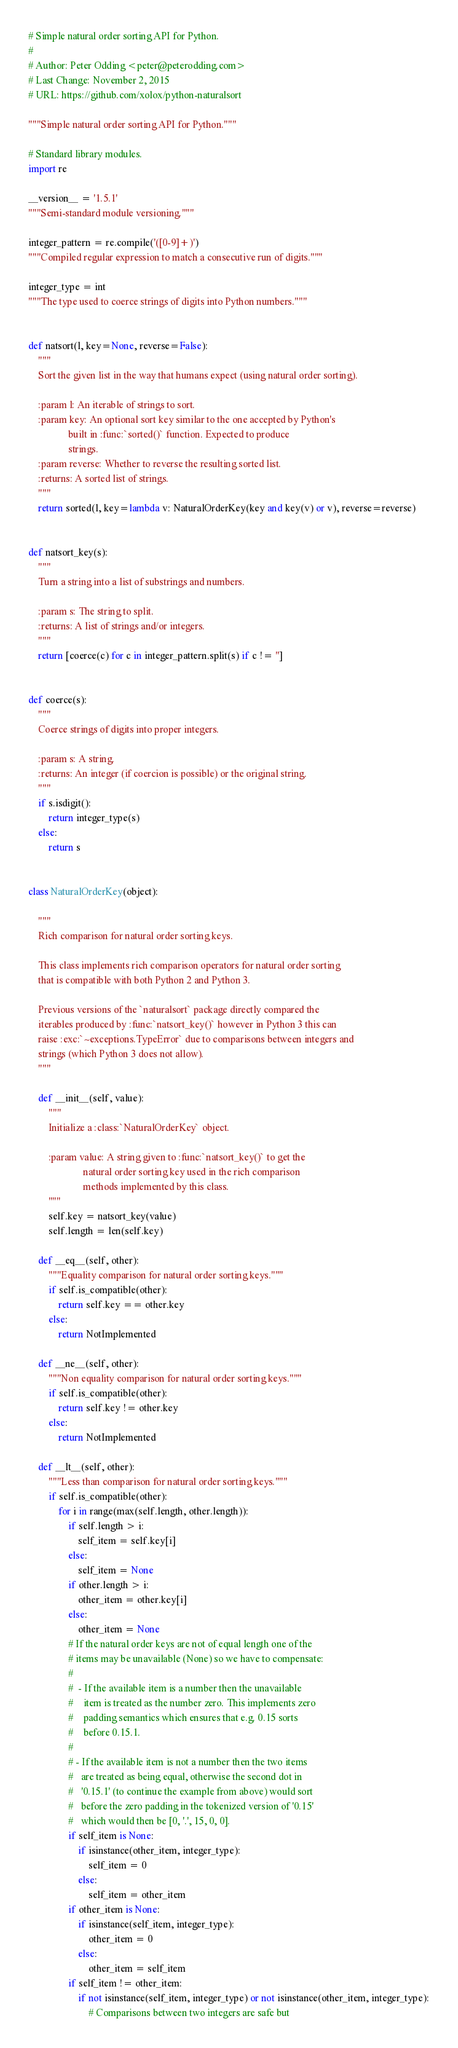<code> <loc_0><loc_0><loc_500><loc_500><_Python_># Simple natural order sorting API for Python.
#
# Author: Peter Odding <peter@peterodding.com>
# Last Change: November 2, 2015
# URL: https://github.com/xolox/python-naturalsort

"""Simple natural order sorting API for Python."""

# Standard library modules.
import re

__version__ = '1.5.1'
"""Semi-standard module versioning."""

integer_pattern = re.compile('([0-9]+)')
"""Compiled regular expression to match a consecutive run of digits."""

integer_type = int
"""The type used to coerce strings of digits into Python numbers."""


def natsort(l, key=None, reverse=False):
    """
    Sort the given list in the way that humans expect (using natural order sorting).

    :param l: An iterable of strings to sort.
    :param key: An optional sort key similar to the one accepted by Python's
                built in :func:`sorted()` function. Expected to produce
                strings.
    :param reverse: Whether to reverse the resulting sorted list.
    :returns: A sorted list of strings.
    """
    return sorted(l, key=lambda v: NaturalOrderKey(key and key(v) or v), reverse=reverse)


def natsort_key(s):
    """
    Turn a string into a list of substrings and numbers.

    :param s: The string to split.
    :returns: A list of strings and/or integers.
    """
    return [coerce(c) for c in integer_pattern.split(s) if c != '']


def coerce(s):
    """
    Coerce strings of digits into proper integers.

    :param s: A string.
    :returns: An integer (if coercion is possible) or the original string.
    """
    if s.isdigit():
        return integer_type(s)
    else:
        return s


class NaturalOrderKey(object):

    """
    Rich comparison for natural order sorting keys.

    This class implements rich comparison operators for natural order sorting
    that is compatible with both Python 2 and Python 3.

    Previous versions of the `naturalsort` package directly compared the
    iterables produced by :func:`natsort_key()` however in Python 3 this can
    raise :exc:`~exceptions.TypeError` due to comparisons between integers and
    strings (which Python 3 does not allow).
    """

    def __init__(self, value):
        """
        Initialize a :class:`NaturalOrderKey` object.

        :param value: A string given to :func:`natsort_key()` to get the
                      natural order sorting key used in the rich comparison
                      methods implemented by this class.
        """
        self.key = natsort_key(value)
        self.length = len(self.key)

    def __eq__(self, other):
        """Equality comparison for natural order sorting keys."""
        if self.is_compatible(other):
            return self.key == other.key
        else:
            return NotImplemented

    def __ne__(self, other):
        """Non equality comparison for natural order sorting keys."""
        if self.is_compatible(other):
            return self.key != other.key
        else:
            return NotImplemented

    def __lt__(self, other):
        """Less than comparison for natural order sorting keys."""
        if self.is_compatible(other):
            for i in range(max(self.length, other.length)):
                if self.length > i:
                    self_item = self.key[i]
                else:
                    self_item = None
                if other.length > i:
                    other_item = other.key[i]
                else:
                    other_item = None
                # If the natural order keys are not of equal length one of the
                # items may be unavailable (None) so we have to compensate:
                #
                #  - If the available item is a number then the unavailable
                #    item is treated as the number zero. This implements zero
                #    padding semantics which ensures that e.g. 0.15 sorts
                #    before 0.15.1.
                #
                # - If the available item is not a number then the two items
                #   are treated as being equal, otherwise the second dot in
                #   '0.15.1' (to continue the example from above) would sort
                #   before the zero padding in the tokenized version of '0.15'
                #   which would then be [0, '.', 15, 0, 0].
                if self_item is None:
                    if isinstance(other_item, integer_type):
                        self_item = 0
                    else:
                        self_item = other_item
                if other_item is None:
                    if isinstance(self_item, integer_type):
                        other_item = 0
                    else:
                        other_item = self_item
                if self_item != other_item:
                    if not isinstance(self_item, integer_type) or not isinstance(other_item, integer_type):
                        # Comparisons between two integers are safe but</code> 